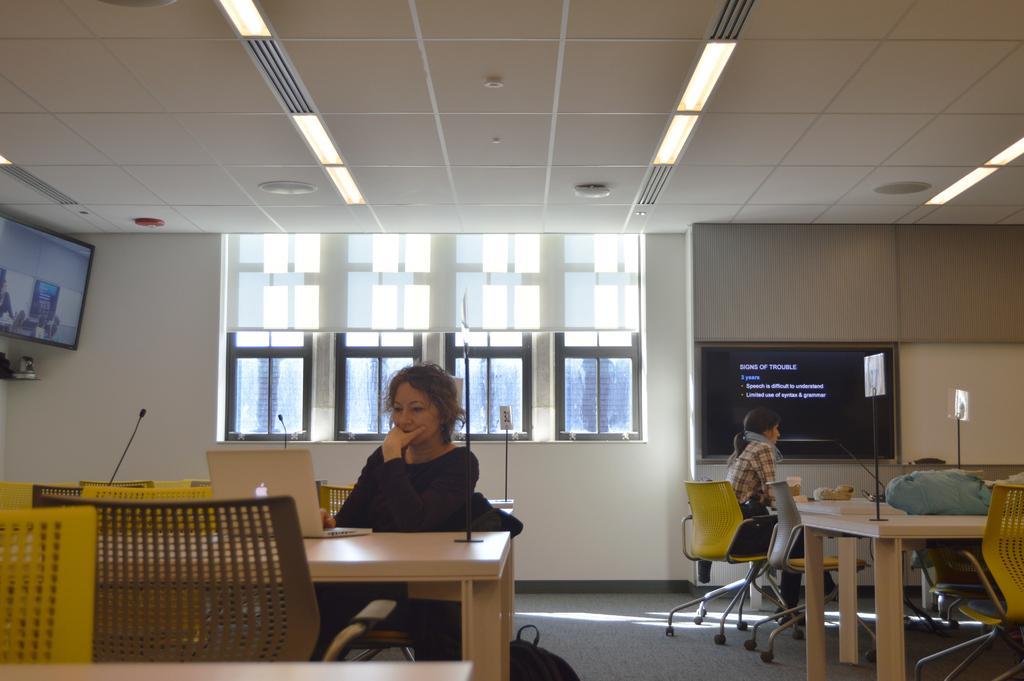Could you give a brief overview of what you see in this image? In this picture we can see two persons sitting on the chairs and looking in to the laptop. This is the table and on the background we can see two screens on the wall. And these are the lights, and this is the floor. And there is a window. 